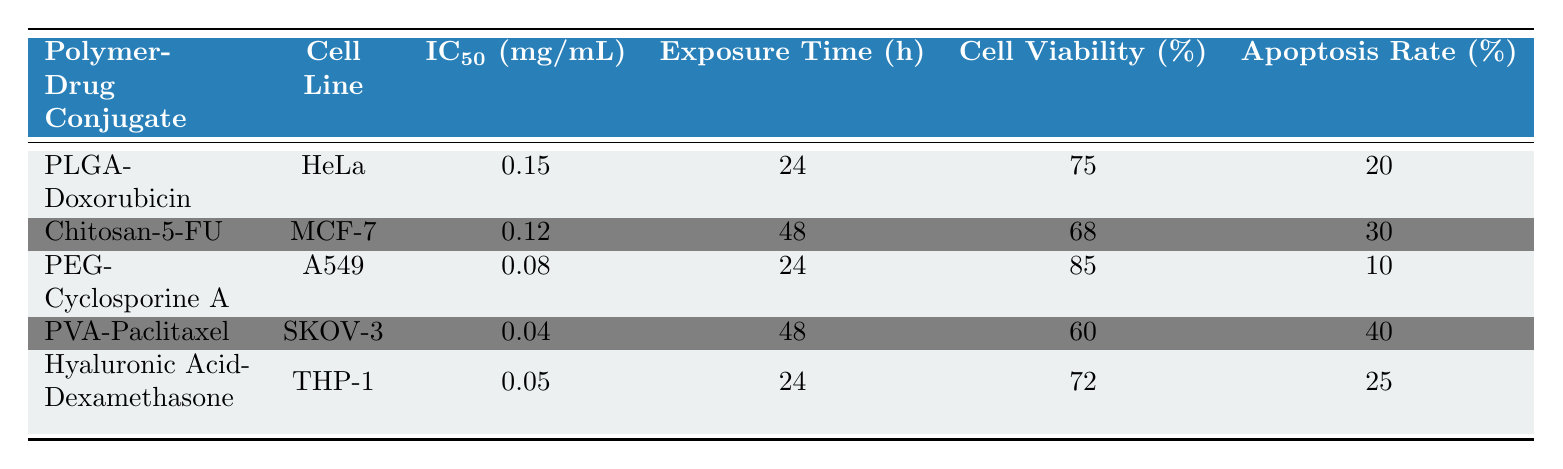What is the IC50 of the polymer-drug conjugate PVA-Paclitaxel? From the table, we look for the entry labeled 'PVA-Paclitaxel' in the polymer-drug conjugate column, which shows an IC50 value of 0.04 mg/mL.
Answer: 0.04 mg/mL Which cell line has the highest apoptosis rate? We review the apoptosis rate percentages from all entries. HeLa has 20%, MCF-7 has 30%, A549 has 10%, SKOV-3 has 40%, and THP-1 has 25%. The maximum value is from SKOV-3 at 40%.
Answer: SKOV-3 Is the exposure time for the Chitosan-5-FU conjugate longer than that for PEG-Cyclosporine A? Checking the exposure times, Chitosan-5-FU has an exposure time of 48 hours, while PEG-Cyclosporine A has an exposure time of 24 hours. Since 48 > 24, the statement is true.
Answer: Yes What is the average cell viability percentage across all polymer-drug conjugates? We sum the cell viability percentages: 75 + 68 + 85 + 60 + 72 = 360. There are 5 data points, so the average is 360 / 5 = 72.
Answer: 72% Which polymer-drug conjugate exhibits the highest cell viability? We compare the cell viability percentages: HeLa has 75%, MCF-7 has 68%, A549 has 85%, SKOV-3 has 60%, and THP-1 has 72%. A549 has the highest at 85%.
Answer: PEG-Cyclosporine A Are any polymer-drug conjugates showing a cell viability percentage of less than 70%? We check the cell viability data; MCF-7 has 68% and SKOV-3 has 60%, both under 70%. Therefore, the answer is yes.
Answer: Yes What is the difference in IC50 values between PVA-Paclitaxel and Chitosan-5-FU? The IC50 for PVA-Paclitaxel is 0.04 mg/mL, while for Chitosan-5-FU it is 0.12 mg/mL. The difference is 0.12 - 0.04 = 0.08 mg/mL.
Answer: 0.08 mg/mL Which cell line has the lowest IC50 value among the tested conjugates? We examine the IC50 values: HeLa (0.15), MCF-7 (0.12), A549 (0.08), SKOV-3 (0.04), and THP-1 (0.05). The lowest is SKOV-3 at 0.04 mg/mL.
Answer: SKOV-3 Is the apoptosis rate for PLGA-Doxorubicin higher than that for PEG-Cyclosporine A? Analyzing the apoptosis rates: PLGA-Doxorubicin has 20%, while PEG-Cyclosporine A has 10%. Since 20 > 10, the statement is true.
Answer: Yes 